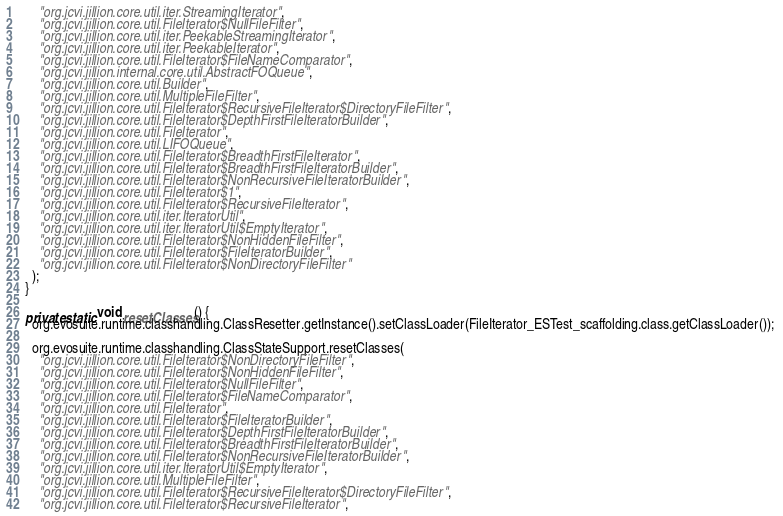Convert code to text. <code><loc_0><loc_0><loc_500><loc_500><_Java_>      "org.jcvi.jillion.core.util.iter.StreamingIterator",
      "org.jcvi.jillion.core.util.FileIterator$NullFileFilter",
      "org.jcvi.jillion.core.util.iter.PeekableStreamingIterator",
      "org.jcvi.jillion.core.util.iter.PeekableIterator",
      "org.jcvi.jillion.core.util.FileIterator$FileNameComparator",
      "org.jcvi.jillion.internal.core.util.AbstractFOQueue",
      "org.jcvi.jillion.core.util.Builder",
      "org.jcvi.jillion.core.util.MultipleFileFilter",
      "org.jcvi.jillion.core.util.FileIterator$RecursiveFileIterator$DirectoryFileFilter",
      "org.jcvi.jillion.core.util.FileIterator$DepthFirstFileIteratorBuilder",
      "org.jcvi.jillion.core.util.FileIterator",
      "org.jcvi.jillion.core.util.LIFOQueue",
      "org.jcvi.jillion.core.util.FileIterator$BreadthFirstFileIterator",
      "org.jcvi.jillion.core.util.FileIterator$BreadthFirstFileIteratorBuilder",
      "org.jcvi.jillion.core.util.FileIterator$NonRecursiveFileIteratorBuilder",
      "org.jcvi.jillion.core.util.FileIterator$1",
      "org.jcvi.jillion.core.util.FileIterator$RecursiveFileIterator",
      "org.jcvi.jillion.core.util.iter.IteratorUtil",
      "org.jcvi.jillion.core.util.iter.IteratorUtil$EmptyIterator",
      "org.jcvi.jillion.core.util.FileIterator$NonHiddenFileFilter",
      "org.jcvi.jillion.core.util.FileIterator$FileIteratorBuilder",
      "org.jcvi.jillion.core.util.FileIterator$NonDirectoryFileFilter"
    );
  } 

  private static void resetClasses() {
    org.evosuite.runtime.classhandling.ClassResetter.getInstance().setClassLoader(FileIterator_ESTest_scaffolding.class.getClassLoader()); 

    org.evosuite.runtime.classhandling.ClassStateSupport.resetClasses(
      "org.jcvi.jillion.core.util.FileIterator$NonDirectoryFileFilter",
      "org.jcvi.jillion.core.util.FileIterator$NonHiddenFileFilter",
      "org.jcvi.jillion.core.util.FileIterator$NullFileFilter",
      "org.jcvi.jillion.core.util.FileIterator$FileNameComparator",
      "org.jcvi.jillion.core.util.FileIterator",
      "org.jcvi.jillion.core.util.FileIterator$FileIteratorBuilder",
      "org.jcvi.jillion.core.util.FileIterator$DepthFirstFileIteratorBuilder",
      "org.jcvi.jillion.core.util.FileIterator$BreadthFirstFileIteratorBuilder",
      "org.jcvi.jillion.core.util.FileIterator$NonRecursiveFileIteratorBuilder",
      "org.jcvi.jillion.core.util.iter.IteratorUtil$EmptyIterator",
      "org.jcvi.jillion.core.util.MultipleFileFilter",
      "org.jcvi.jillion.core.util.FileIterator$RecursiveFileIterator$DirectoryFileFilter",
      "org.jcvi.jillion.core.util.FileIterator$RecursiveFileIterator",</code> 